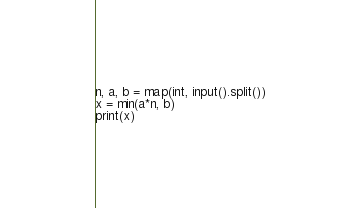<code> <loc_0><loc_0><loc_500><loc_500><_Python_>n, a, b = map(int, input().split())
x = min(a*n, b)
print(x)
</code> 